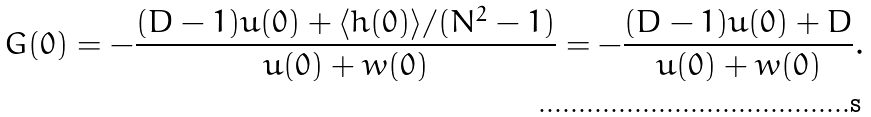Convert formula to latex. <formula><loc_0><loc_0><loc_500><loc_500>G ( 0 ) = - \frac { ( D - 1 ) u ( 0 ) + \langle h ( 0 ) \rangle / ( N ^ { 2 } - 1 ) } { u ( 0 ) + w ( 0 ) } = - \frac { ( D - 1 ) u ( 0 ) + D } { u ( 0 ) + w ( 0 ) } .</formula> 